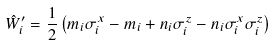<formula> <loc_0><loc_0><loc_500><loc_500>\hat { W } _ { i } ^ { \prime } = \frac { 1 } { 2 } \left ( m _ { i } \sigma _ { i } ^ { x } - m _ { i } + n _ { i } \sigma _ { i } ^ { z } - n _ { i } \sigma _ { i } ^ { x } \sigma _ { i } ^ { z } \right )</formula> 